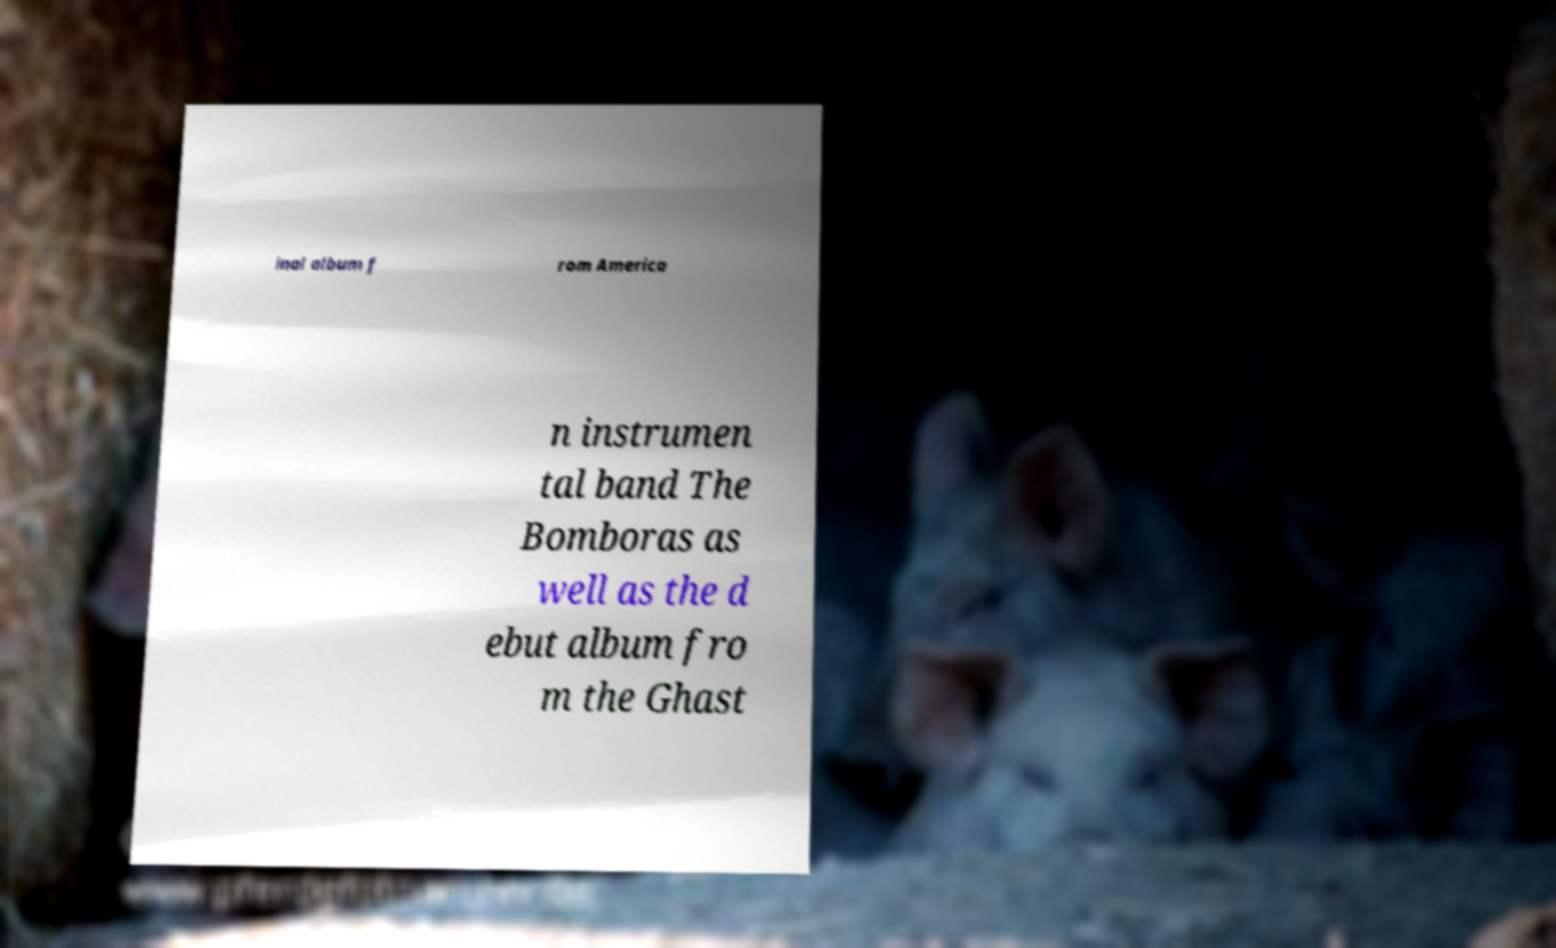What messages or text are displayed in this image? I need them in a readable, typed format. inal album f rom America n instrumen tal band The Bomboras as well as the d ebut album fro m the Ghast 